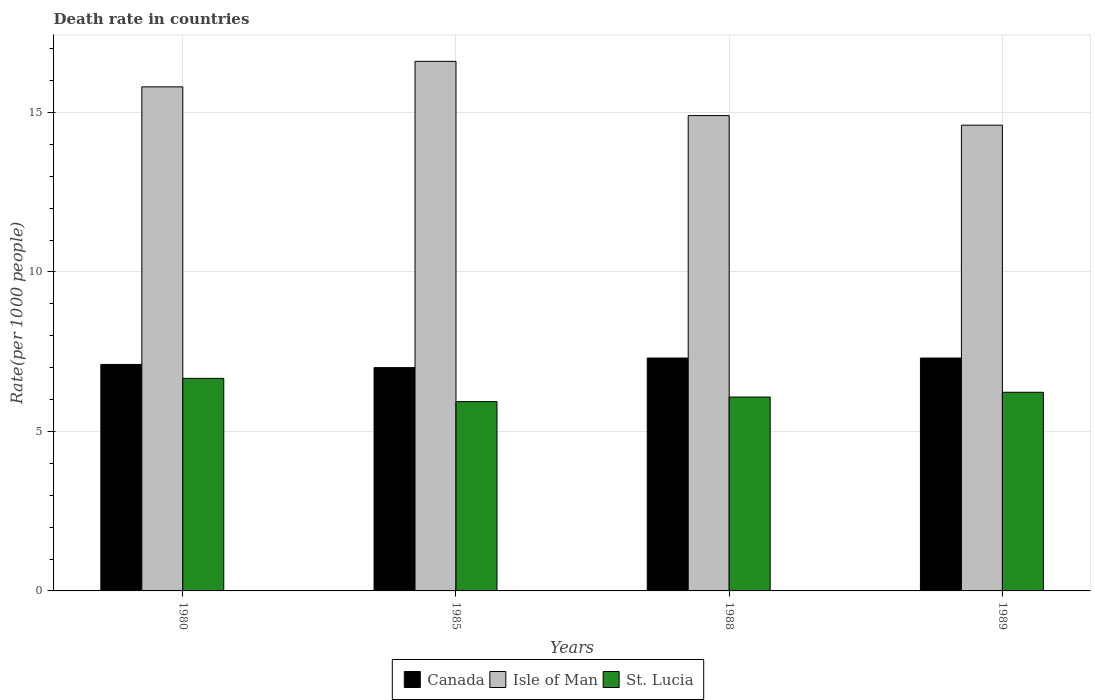How many bars are there on the 3rd tick from the left?
Offer a very short reply. 3. What is the label of the 1st group of bars from the left?
Ensure brevity in your answer.  1980. In how many cases, is the number of bars for a given year not equal to the number of legend labels?
Your answer should be compact. 0. Across all years, what is the maximum death rate in St. Lucia?
Keep it short and to the point. 6.66. In which year was the death rate in St. Lucia maximum?
Keep it short and to the point. 1980. In which year was the death rate in Canada minimum?
Make the answer very short. 1985. What is the total death rate in Canada in the graph?
Your response must be concise. 28.7. What is the difference between the death rate in St. Lucia in 1988 and that in 1989?
Your response must be concise. -0.15. What is the difference between the death rate in St. Lucia in 1989 and the death rate in Isle of Man in 1985?
Your answer should be very brief. -10.37. What is the average death rate in Canada per year?
Keep it short and to the point. 7.17. In the year 1985, what is the difference between the death rate in Canada and death rate in Isle of Man?
Your response must be concise. -9.6. In how many years, is the death rate in Isle of Man greater than 5?
Give a very brief answer. 4. What is the ratio of the death rate in Canada in 1985 to that in 1988?
Offer a very short reply. 0.96. What is the difference between the highest and the second highest death rate in St. Lucia?
Provide a succinct answer. 0.44. What is the difference between the highest and the lowest death rate in Canada?
Ensure brevity in your answer.  0.3. What does the 2nd bar from the left in 1988 represents?
Ensure brevity in your answer.  Isle of Man. What does the 3rd bar from the right in 1989 represents?
Your answer should be very brief. Canada. Are all the bars in the graph horizontal?
Your answer should be compact. No. Does the graph contain grids?
Your response must be concise. Yes. Where does the legend appear in the graph?
Offer a very short reply. Bottom center. How are the legend labels stacked?
Offer a very short reply. Horizontal. What is the title of the graph?
Your answer should be very brief. Death rate in countries. What is the label or title of the Y-axis?
Your response must be concise. Rate(per 1000 people). What is the Rate(per 1000 people) of Canada in 1980?
Keep it short and to the point. 7.1. What is the Rate(per 1000 people) of St. Lucia in 1980?
Keep it short and to the point. 6.66. What is the Rate(per 1000 people) in Isle of Man in 1985?
Keep it short and to the point. 16.6. What is the Rate(per 1000 people) in St. Lucia in 1985?
Ensure brevity in your answer.  5.93. What is the Rate(per 1000 people) of Canada in 1988?
Your answer should be compact. 7.3. What is the Rate(per 1000 people) of St. Lucia in 1988?
Offer a very short reply. 6.08. What is the Rate(per 1000 people) in Isle of Man in 1989?
Your answer should be compact. 14.6. What is the Rate(per 1000 people) of St. Lucia in 1989?
Provide a short and direct response. 6.23. Across all years, what is the maximum Rate(per 1000 people) in Isle of Man?
Your answer should be very brief. 16.6. Across all years, what is the maximum Rate(per 1000 people) of St. Lucia?
Your response must be concise. 6.66. Across all years, what is the minimum Rate(per 1000 people) in Canada?
Your response must be concise. 7. Across all years, what is the minimum Rate(per 1000 people) in Isle of Man?
Your answer should be compact. 14.6. Across all years, what is the minimum Rate(per 1000 people) in St. Lucia?
Offer a terse response. 5.93. What is the total Rate(per 1000 people) in Canada in the graph?
Give a very brief answer. 28.7. What is the total Rate(per 1000 people) of Isle of Man in the graph?
Provide a short and direct response. 61.9. What is the total Rate(per 1000 people) in St. Lucia in the graph?
Provide a short and direct response. 24.9. What is the difference between the Rate(per 1000 people) in Canada in 1980 and that in 1985?
Offer a very short reply. 0.1. What is the difference between the Rate(per 1000 people) of St. Lucia in 1980 and that in 1985?
Offer a very short reply. 0.73. What is the difference between the Rate(per 1000 people) of Isle of Man in 1980 and that in 1988?
Offer a very short reply. 0.9. What is the difference between the Rate(per 1000 people) in St. Lucia in 1980 and that in 1988?
Your answer should be very brief. 0.59. What is the difference between the Rate(per 1000 people) of Isle of Man in 1980 and that in 1989?
Your answer should be very brief. 1.2. What is the difference between the Rate(per 1000 people) in St. Lucia in 1980 and that in 1989?
Keep it short and to the point. 0.44. What is the difference between the Rate(per 1000 people) in Canada in 1985 and that in 1988?
Your answer should be compact. -0.3. What is the difference between the Rate(per 1000 people) in St. Lucia in 1985 and that in 1988?
Give a very brief answer. -0.14. What is the difference between the Rate(per 1000 people) of St. Lucia in 1985 and that in 1989?
Your answer should be compact. -0.29. What is the difference between the Rate(per 1000 people) of Canada in 1988 and that in 1989?
Make the answer very short. 0. What is the difference between the Rate(per 1000 people) in St. Lucia in 1988 and that in 1989?
Offer a terse response. -0.15. What is the difference between the Rate(per 1000 people) of Canada in 1980 and the Rate(per 1000 people) of Isle of Man in 1985?
Ensure brevity in your answer.  -9.5. What is the difference between the Rate(per 1000 people) of Canada in 1980 and the Rate(per 1000 people) of St. Lucia in 1985?
Give a very brief answer. 1.17. What is the difference between the Rate(per 1000 people) of Isle of Man in 1980 and the Rate(per 1000 people) of St. Lucia in 1985?
Your answer should be very brief. 9.87. What is the difference between the Rate(per 1000 people) in Canada in 1980 and the Rate(per 1000 people) in Isle of Man in 1988?
Keep it short and to the point. -7.8. What is the difference between the Rate(per 1000 people) in Canada in 1980 and the Rate(per 1000 people) in St. Lucia in 1988?
Provide a succinct answer. 1.02. What is the difference between the Rate(per 1000 people) in Isle of Man in 1980 and the Rate(per 1000 people) in St. Lucia in 1988?
Your answer should be compact. 9.72. What is the difference between the Rate(per 1000 people) in Canada in 1980 and the Rate(per 1000 people) in St. Lucia in 1989?
Ensure brevity in your answer.  0.87. What is the difference between the Rate(per 1000 people) of Isle of Man in 1980 and the Rate(per 1000 people) of St. Lucia in 1989?
Offer a very short reply. 9.57. What is the difference between the Rate(per 1000 people) of Canada in 1985 and the Rate(per 1000 people) of Isle of Man in 1988?
Ensure brevity in your answer.  -7.9. What is the difference between the Rate(per 1000 people) in Canada in 1985 and the Rate(per 1000 people) in St. Lucia in 1988?
Provide a succinct answer. 0.92. What is the difference between the Rate(per 1000 people) in Isle of Man in 1985 and the Rate(per 1000 people) in St. Lucia in 1988?
Your answer should be very brief. 10.52. What is the difference between the Rate(per 1000 people) in Canada in 1985 and the Rate(per 1000 people) in Isle of Man in 1989?
Provide a succinct answer. -7.6. What is the difference between the Rate(per 1000 people) of Canada in 1985 and the Rate(per 1000 people) of St. Lucia in 1989?
Give a very brief answer. 0.77. What is the difference between the Rate(per 1000 people) of Isle of Man in 1985 and the Rate(per 1000 people) of St. Lucia in 1989?
Ensure brevity in your answer.  10.37. What is the difference between the Rate(per 1000 people) of Canada in 1988 and the Rate(per 1000 people) of Isle of Man in 1989?
Offer a terse response. -7.3. What is the difference between the Rate(per 1000 people) of Canada in 1988 and the Rate(per 1000 people) of St. Lucia in 1989?
Your response must be concise. 1.07. What is the difference between the Rate(per 1000 people) of Isle of Man in 1988 and the Rate(per 1000 people) of St. Lucia in 1989?
Your answer should be compact. 8.67. What is the average Rate(per 1000 people) in Canada per year?
Make the answer very short. 7.17. What is the average Rate(per 1000 people) in Isle of Man per year?
Keep it short and to the point. 15.47. What is the average Rate(per 1000 people) in St. Lucia per year?
Offer a terse response. 6.23. In the year 1980, what is the difference between the Rate(per 1000 people) of Canada and Rate(per 1000 people) of St. Lucia?
Make the answer very short. 0.44. In the year 1980, what is the difference between the Rate(per 1000 people) in Isle of Man and Rate(per 1000 people) in St. Lucia?
Your answer should be very brief. 9.14. In the year 1985, what is the difference between the Rate(per 1000 people) of Canada and Rate(per 1000 people) of Isle of Man?
Offer a very short reply. -9.6. In the year 1985, what is the difference between the Rate(per 1000 people) of Canada and Rate(per 1000 people) of St. Lucia?
Ensure brevity in your answer.  1.07. In the year 1985, what is the difference between the Rate(per 1000 people) in Isle of Man and Rate(per 1000 people) in St. Lucia?
Ensure brevity in your answer.  10.67. In the year 1988, what is the difference between the Rate(per 1000 people) in Canada and Rate(per 1000 people) in St. Lucia?
Your answer should be very brief. 1.22. In the year 1988, what is the difference between the Rate(per 1000 people) in Isle of Man and Rate(per 1000 people) in St. Lucia?
Ensure brevity in your answer.  8.82. In the year 1989, what is the difference between the Rate(per 1000 people) of Canada and Rate(per 1000 people) of Isle of Man?
Provide a succinct answer. -7.3. In the year 1989, what is the difference between the Rate(per 1000 people) in Canada and Rate(per 1000 people) in St. Lucia?
Offer a very short reply. 1.07. In the year 1989, what is the difference between the Rate(per 1000 people) of Isle of Man and Rate(per 1000 people) of St. Lucia?
Make the answer very short. 8.37. What is the ratio of the Rate(per 1000 people) in Canada in 1980 to that in 1985?
Provide a succinct answer. 1.01. What is the ratio of the Rate(per 1000 people) of Isle of Man in 1980 to that in 1985?
Make the answer very short. 0.95. What is the ratio of the Rate(per 1000 people) in St. Lucia in 1980 to that in 1985?
Your response must be concise. 1.12. What is the ratio of the Rate(per 1000 people) in Canada in 1980 to that in 1988?
Keep it short and to the point. 0.97. What is the ratio of the Rate(per 1000 people) of Isle of Man in 1980 to that in 1988?
Provide a succinct answer. 1.06. What is the ratio of the Rate(per 1000 people) of St. Lucia in 1980 to that in 1988?
Ensure brevity in your answer.  1.1. What is the ratio of the Rate(per 1000 people) of Canada in 1980 to that in 1989?
Your answer should be very brief. 0.97. What is the ratio of the Rate(per 1000 people) in Isle of Man in 1980 to that in 1989?
Provide a short and direct response. 1.08. What is the ratio of the Rate(per 1000 people) of St. Lucia in 1980 to that in 1989?
Offer a very short reply. 1.07. What is the ratio of the Rate(per 1000 people) of Canada in 1985 to that in 1988?
Make the answer very short. 0.96. What is the ratio of the Rate(per 1000 people) in Isle of Man in 1985 to that in 1988?
Provide a succinct answer. 1.11. What is the ratio of the Rate(per 1000 people) in St. Lucia in 1985 to that in 1988?
Your response must be concise. 0.98. What is the ratio of the Rate(per 1000 people) in Canada in 1985 to that in 1989?
Ensure brevity in your answer.  0.96. What is the ratio of the Rate(per 1000 people) in Isle of Man in 1985 to that in 1989?
Provide a short and direct response. 1.14. What is the ratio of the Rate(per 1000 people) in St. Lucia in 1985 to that in 1989?
Offer a very short reply. 0.95. What is the ratio of the Rate(per 1000 people) in Canada in 1988 to that in 1989?
Provide a short and direct response. 1. What is the ratio of the Rate(per 1000 people) in Isle of Man in 1988 to that in 1989?
Ensure brevity in your answer.  1.02. What is the ratio of the Rate(per 1000 people) of St. Lucia in 1988 to that in 1989?
Your answer should be compact. 0.98. What is the difference between the highest and the second highest Rate(per 1000 people) of St. Lucia?
Make the answer very short. 0.44. What is the difference between the highest and the lowest Rate(per 1000 people) of Isle of Man?
Keep it short and to the point. 2. What is the difference between the highest and the lowest Rate(per 1000 people) in St. Lucia?
Give a very brief answer. 0.73. 